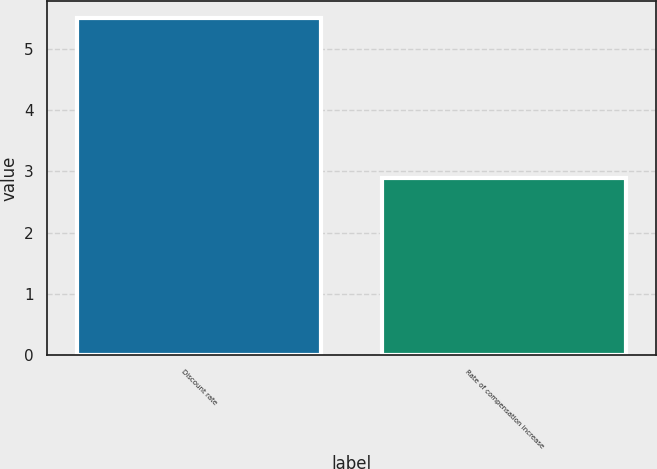Convert chart to OTSL. <chart><loc_0><loc_0><loc_500><loc_500><bar_chart><fcel>Discount rate<fcel>Rate of compensation increase<nl><fcel>5.5<fcel>2.9<nl></chart> 